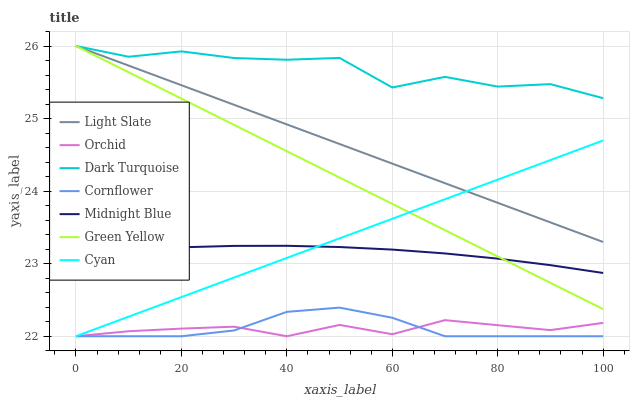Does Orchid have the minimum area under the curve?
Answer yes or no. Yes. Does Dark Turquoise have the maximum area under the curve?
Answer yes or no. Yes. Does Midnight Blue have the minimum area under the curve?
Answer yes or no. No. Does Midnight Blue have the maximum area under the curve?
Answer yes or no. No. Is Green Yellow the smoothest?
Answer yes or no. Yes. Is Dark Turquoise the roughest?
Answer yes or no. Yes. Is Midnight Blue the smoothest?
Answer yes or no. No. Is Midnight Blue the roughest?
Answer yes or no. No. Does Cornflower have the lowest value?
Answer yes or no. Yes. Does Midnight Blue have the lowest value?
Answer yes or no. No. Does Green Yellow have the highest value?
Answer yes or no. Yes. Does Midnight Blue have the highest value?
Answer yes or no. No. Is Cornflower less than Dark Turquoise?
Answer yes or no. Yes. Is Light Slate greater than Cornflower?
Answer yes or no. Yes. Does Cyan intersect Cornflower?
Answer yes or no. Yes. Is Cyan less than Cornflower?
Answer yes or no. No. Is Cyan greater than Cornflower?
Answer yes or no. No. Does Cornflower intersect Dark Turquoise?
Answer yes or no. No. 